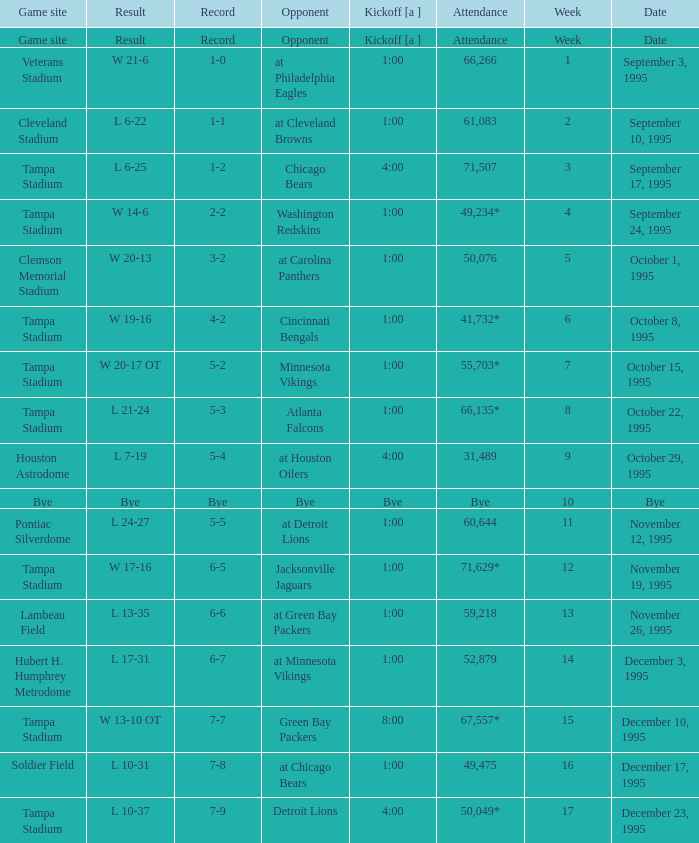Who did the Tampa Bay Buccaneers play on december 23, 1995? Detroit Lions. 